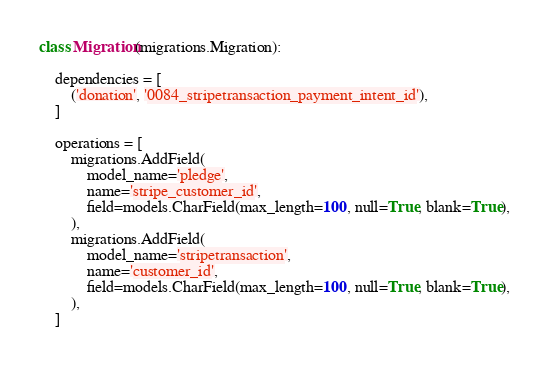<code> <loc_0><loc_0><loc_500><loc_500><_Python_>

class Migration(migrations.Migration):

    dependencies = [
        ('donation', '0084_stripetransaction_payment_intent_id'),
    ]

    operations = [
        migrations.AddField(
            model_name='pledge',
            name='stripe_customer_id',
            field=models.CharField(max_length=100, null=True, blank=True),
        ),
        migrations.AddField(
            model_name='stripetransaction',
            name='customer_id',
            field=models.CharField(max_length=100, null=True, blank=True),
        ),
    ]
</code> 